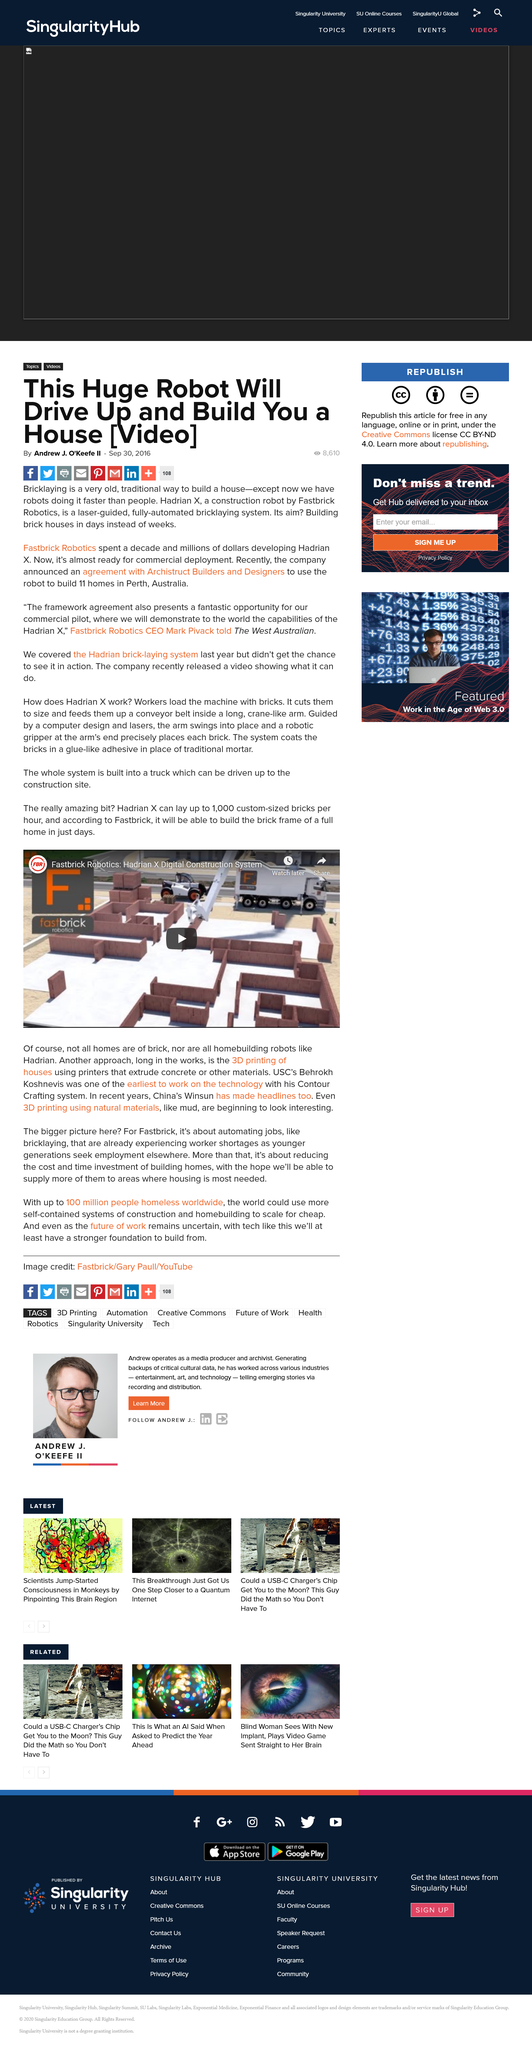Highlight a few significant elements in this photo. The CEO of Fastbrick Robotics was interviewed by The West Australian newspaper. Mark Pivack is the CEO of the company that developed Hadrian X. The robot will build houses in Perth under the agreement with Archistruct Builders and Designers. 